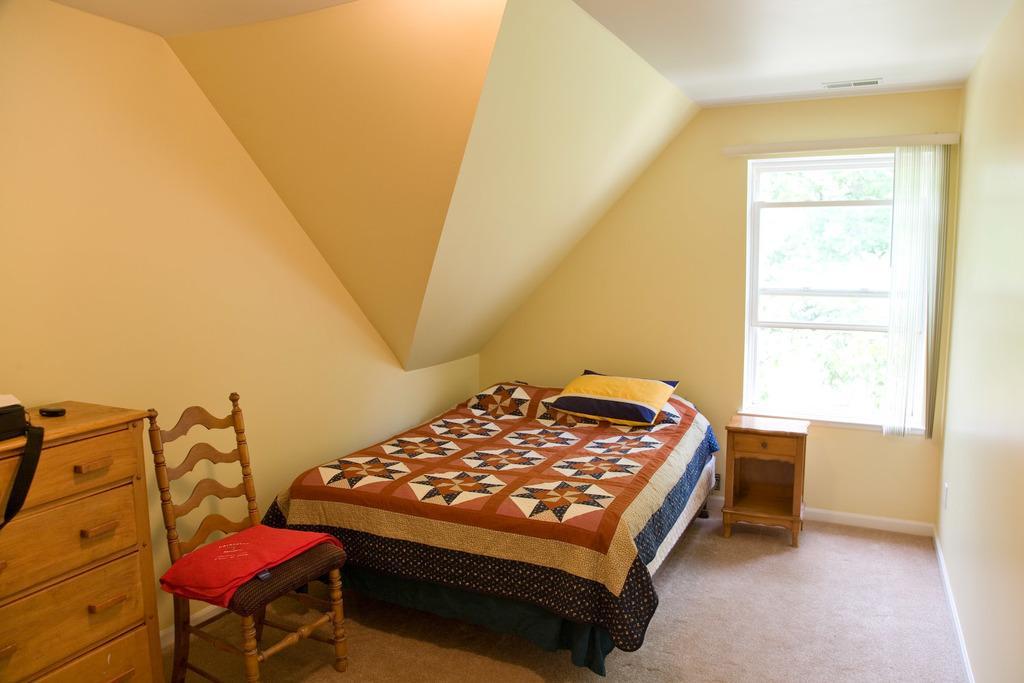How would you summarize this image in a sentence or two? On the background we can see wall, window with curtain. This is a floor. Here we can see a desk, here on this desk we can see a bag. This is a chair with pillow. This is a bed with bedsheet and pillow. 